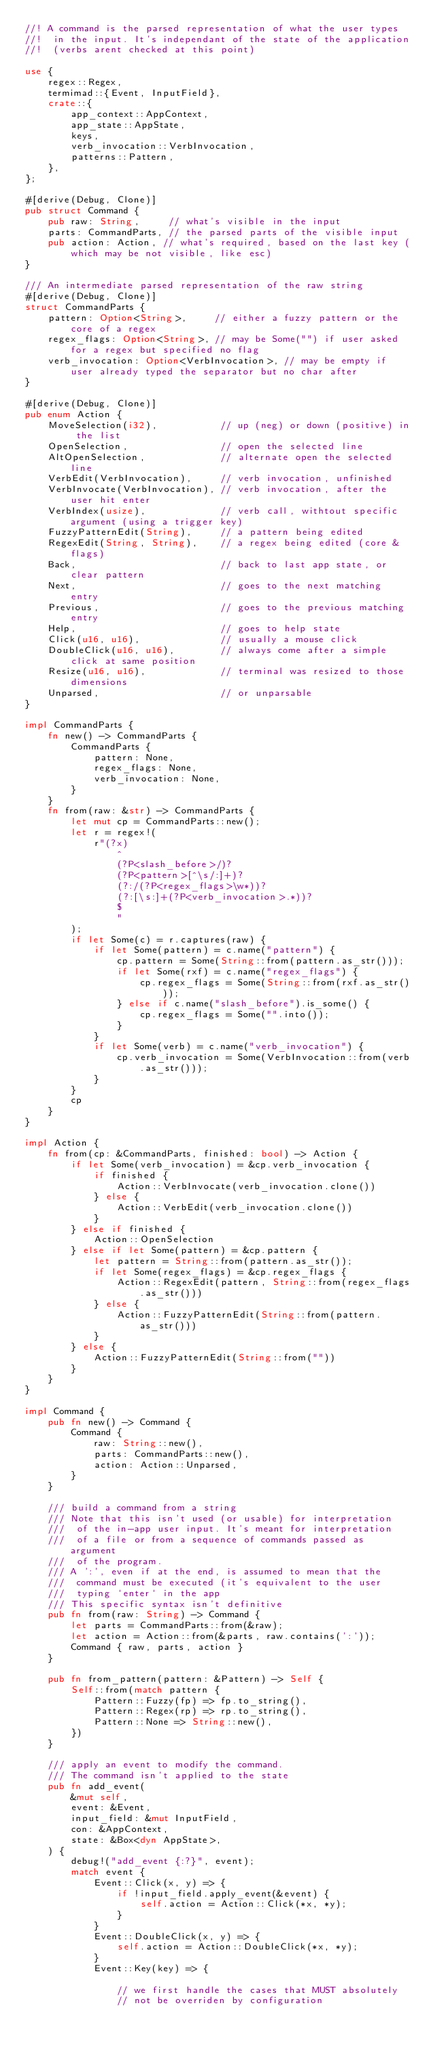<code> <loc_0><loc_0><loc_500><loc_500><_Rust_>//! A command is the parsed representation of what the user types
//!  in the input. It's independant of the state of the application
//!  (verbs arent checked at this point)

use {
    regex::Regex,
    termimad::{Event, InputField},
    crate::{
        app_context::AppContext,
        app_state::AppState,
        keys,
        verb_invocation::VerbInvocation,
        patterns::Pattern,
    },
};

#[derive(Debug, Clone)]
pub struct Command {
    pub raw: String,     // what's visible in the input
    parts: CommandParts, // the parsed parts of the visible input
    pub action: Action, // what's required, based on the last key (which may be not visible, like esc)
}

/// An intermediate parsed representation of the raw string
#[derive(Debug, Clone)]
struct CommandParts {
    pattern: Option<String>,     // either a fuzzy pattern or the core of a regex
    regex_flags: Option<String>, // may be Some("") if user asked for a regex but specified no flag
    verb_invocation: Option<VerbInvocation>, // may be empty if user already typed the separator but no char after
}

#[derive(Debug, Clone)]
pub enum Action {
    MoveSelection(i32),           // up (neg) or down (positive) in the list
    OpenSelection,                // open the selected line
    AltOpenSelection,             // alternate open the selected line
    VerbEdit(VerbInvocation),     // verb invocation, unfinished
    VerbInvocate(VerbInvocation), // verb invocation, after the user hit enter
    VerbIndex(usize),             // verb call, withtout specific argument (using a trigger key)
    FuzzyPatternEdit(String),     // a pattern being edited
    RegexEdit(String, String),    // a regex being edited (core & flags)
    Back,                         // back to last app state, or clear pattern
    Next,                         // goes to the next matching entry
    Previous,                     // goes to the previous matching entry
    Help,                         // goes to help state
    Click(u16, u16),              // usually a mouse click
    DoubleClick(u16, u16),        // always come after a simple click at same position
    Resize(u16, u16),             // terminal was resized to those dimensions
    Unparsed,                     // or unparsable
}

impl CommandParts {
    fn new() -> CommandParts {
        CommandParts {
            pattern: None,
            regex_flags: None,
            verb_invocation: None,
        }
    }
    fn from(raw: &str) -> CommandParts {
        let mut cp = CommandParts::new();
        let r = regex!(
            r"(?x)
                ^
                (?P<slash_before>/)?
                (?P<pattern>[^\s/:]+)?
                (?:/(?P<regex_flags>\w*))?
                (?:[\s:]+(?P<verb_invocation>.*))?
                $
                "
        );
        if let Some(c) = r.captures(raw) {
            if let Some(pattern) = c.name("pattern") {
                cp.pattern = Some(String::from(pattern.as_str()));
                if let Some(rxf) = c.name("regex_flags") {
                    cp.regex_flags = Some(String::from(rxf.as_str()));
                } else if c.name("slash_before").is_some() {
                    cp.regex_flags = Some("".into());
                }
            }
            if let Some(verb) = c.name("verb_invocation") {
                cp.verb_invocation = Some(VerbInvocation::from(verb.as_str()));
            }
        }
        cp
    }
}

impl Action {
    fn from(cp: &CommandParts, finished: bool) -> Action {
        if let Some(verb_invocation) = &cp.verb_invocation {
            if finished {
                Action::VerbInvocate(verb_invocation.clone())
            } else {
                Action::VerbEdit(verb_invocation.clone())
            }
        } else if finished {
            Action::OpenSelection
        } else if let Some(pattern) = &cp.pattern {
            let pattern = String::from(pattern.as_str());
            if let Some(regex_flags) = &cp.regex_flags {
                Action::RegexEdit(pattern, String::from(regex_flags.as_str()))
            } else {
                Action::FuzzyPatternEdit(String::from(pattern.as_str()))
            }
        } else {
            Action::FuzzyPatternEdit(String::from(""))
        }
    }
}

impl Command {
    pub fn new() -> Command {
        Command {
            raw: String::new(),
            parts: CommandParts::new(),
            action: Action::Unparsed,
        }
    }

    /// build a command from a string
    /// Note that this isn't used (or usable) for interpretation
    ///  of the in-app user input. It's meant for interpretation
    ///  of a file or from a sequence of commands passed as argument
    ///  of the program.
    /// A ':', even if at the end, is assumed to mean that the
    ///  command must be executed (it's equivalent to the user
    ///  typing `enter` in the app
    /// This specific syntax isn't definitive
    pub fn from(raw: String) -> Command {
        let parts = CommandParts::from(&raw);
        let action = Action::from(&parts, raw.contains(':'));
        Command { raw, parts, action }
    }

    pub fn from_pattern(pattern: &Pattern) -> Self {
        Self::from(match pattern {
            Pattern::Fuzzy(fp) => fp.to_string(),
            Pattern::Regex(rp) => rp.to_string(),
            Pattern::None => String::new(),
        })
    }

    /// apply an event to modify the command.
    /// The command isn't applied to the state
    pub fn add_event(
        &mut self,
        event: &Event,
        input_field: &mut InputField,
        con: &AppContext,
        state: &Box<dyn AppState>,
    ) {
        debug!("add_event {:?}", event);
        match event {
            Event::Click(x, y) => {
                if !input_field.apply_event(&event) {
                    self.action = Action::Click(*x, *y);
                }
            }
            Event::DoubleClick(x, y) => {
                self.action = Action::DoubleClick(*x, *y);
            }
            Event::Key(key) => {

                // we first handle the cases that MUST absolutely
                // not be overriden by configuration
</code> 